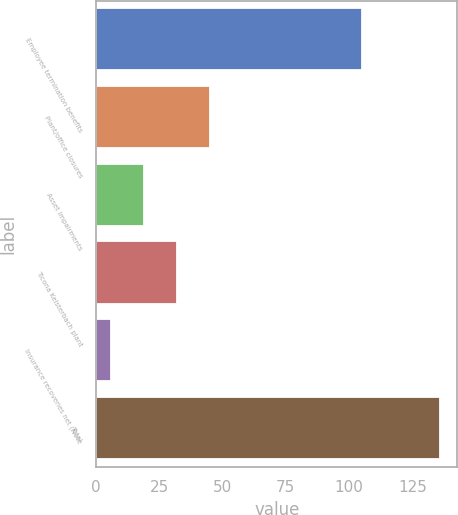<chart> <loc_0><loc_0><loc_500><loc_500><bar_chart><fcel>Employee termination benefits<fcel>Plant/office closures<fcel>Asset impairments<fcel>Ticona Kelsterbach plant<fcel>Insurance recoveries net (Note<fcel>Total<nl><fcel>105<fcel>45<fcel>19<fcel>32<fcel>6<fcel>136<nl></chart> 